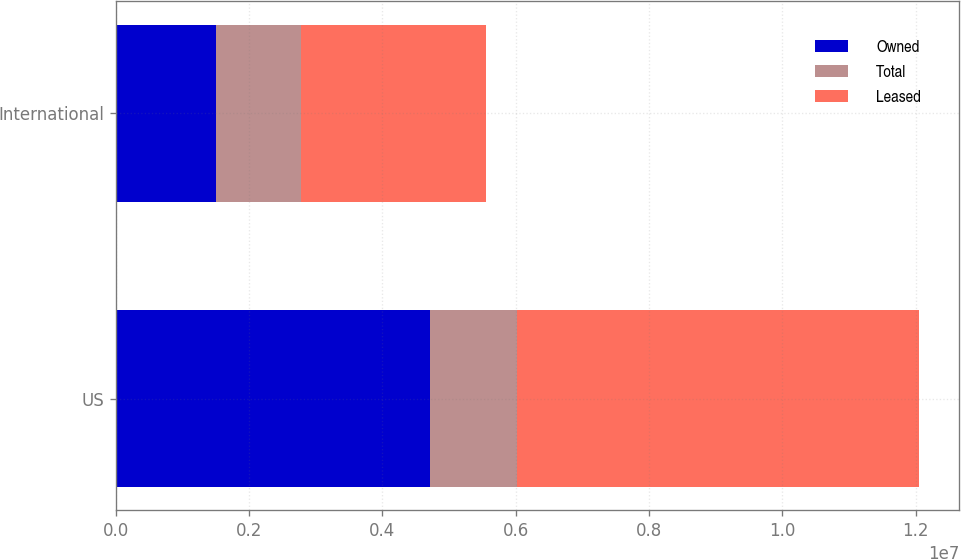Convert chart. <chart><loc_0><loc_0><loc_500><loc_500><stacked_bar_chart><ecel><fcel>US<fcel>International<nl><fcel>Owned<fcel>4.714e+06<fcel>1.512e+06<nl><fcel>Total<fcel>1.314e+06<fcel>1.264e+06<nl><fcel>Leased<fcel>6.028e+06<fcel>2.776e+06<nl></chart> 